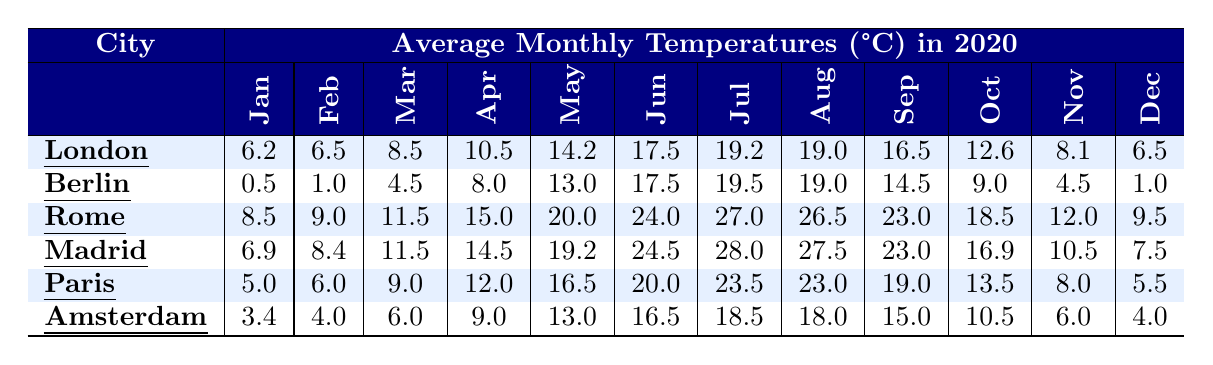What is the average temperature in London during July? In the table, under the column for London and row for July, the value is 19.2. Thus, the average temperature in London for July is directly observed as 19.2°C.
Answer: 19.2°C Which city has the highest average temperature in August? Looking through the August column for all cities, Rome has an average temperature of 26.5°C, which is the highest among the listed cities.
Answer: Rome What is the temperature difference between the coldest month and the warmest month in Berlin? In Berlin, the coldest month is January with an average temperature of 0.5°C and the warmest month is July with 19.5°C. The difference is calculated as 19.5°C - 0.5°C = 19.0°C.
Answer: 19.0°C Which month has the lowest average temperature in Amsterdam? Reviewing the data for Amsterdam, January has the lowest average temperature at 3.4°C compared to other months.
Answer: January Is the average temperature in Paris higher in June than in October? Checking the June average temperature for Paris, it is 20.0°C, whereas in October it is 13.5°C. Since 20.0°C is greater than 13.5°C, the statement is true.
Answer: Yes What is the average temperature for Rome over the first half of the year (January to June)? We take the temperatures from January (8.5), February (9.0), March (11.5), April (15.0), May (20.0), and June (24.0), then sum them: 8.5 + 9.0 + 11.5 + 15.0 + 20.0 + 24.0 = 88.0. To find the average, we divide by 6 (the number of months), resulting in 88.0/6 = approximately 14.67°C.
Answer: 14.67°C Which city has a monthly temperature in May that is lower than 16°C? From the May row, London has an average temperature of 14.2°C, which is lower than 16°C, whereas the other cities have temperatures equal to or greater than 16°C.
Answer: London In which city is the average temperature in December warmer than in November? Checking the December and November temperatures for the cities, only Madrid has an average temperature of 7.5°C in December which is higher than 10.5°C in November.
Answer: Madrid What is the total sum of average temperatures for the month of March across all cities? Adding the March averages: London (8.5) + Berlin (4.5) + Rome (11.5) + Madrid (11.5) + Paris (9.0) + Amsterdam (6.0) gives a total of 51.0°C.
Answer: 51.0°C Does Berlin have a higher average temperature in April than Paris? The average temperature in Berlin for April is 8.0°C, while Paris shows 12.0°C for the same month. Since 8.0°C is less than 12.0°C, the statement is false.
Answer: No Which city experiences the largest temperature increase from January to July? The increase for each city is calculated as follows: London (19.2 - 6.2 = 13.0°C), Berlin (19.5 - 0.5 = 19.0°C), Rome (27.0 - 8.5 = 18.5°C), Madrid (28.0 - 6.9 = 21.1°C), Paris (23.5 - 5.0 = 18.5°C), and Amsterdam (18.5 - 3.4 = 15.1°C). The largest increase is Madrid with 21.1°C.
Answer: Madrid 